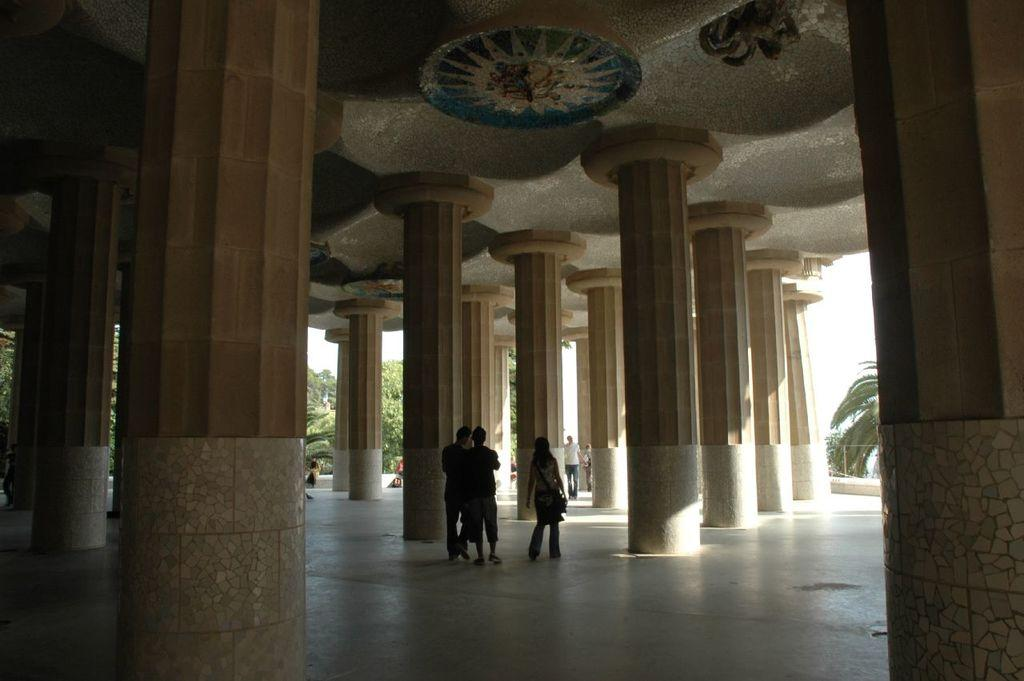What architectural feature can be seen in the image? There are pillars in the image. What is the surface that the people are standing on? The people are standing on the ground in the image. What is above the people and pillars in the image? There is a ceiling visible in the image. What can be seen in the distance behind the people and pillars? There are trees and the sky visible in the background of the image. What type of comb is being used by the person in the image? There is no person using a comb in the image; the focus is on the pillars, people standing on the ground, the ceiling, and the background. 